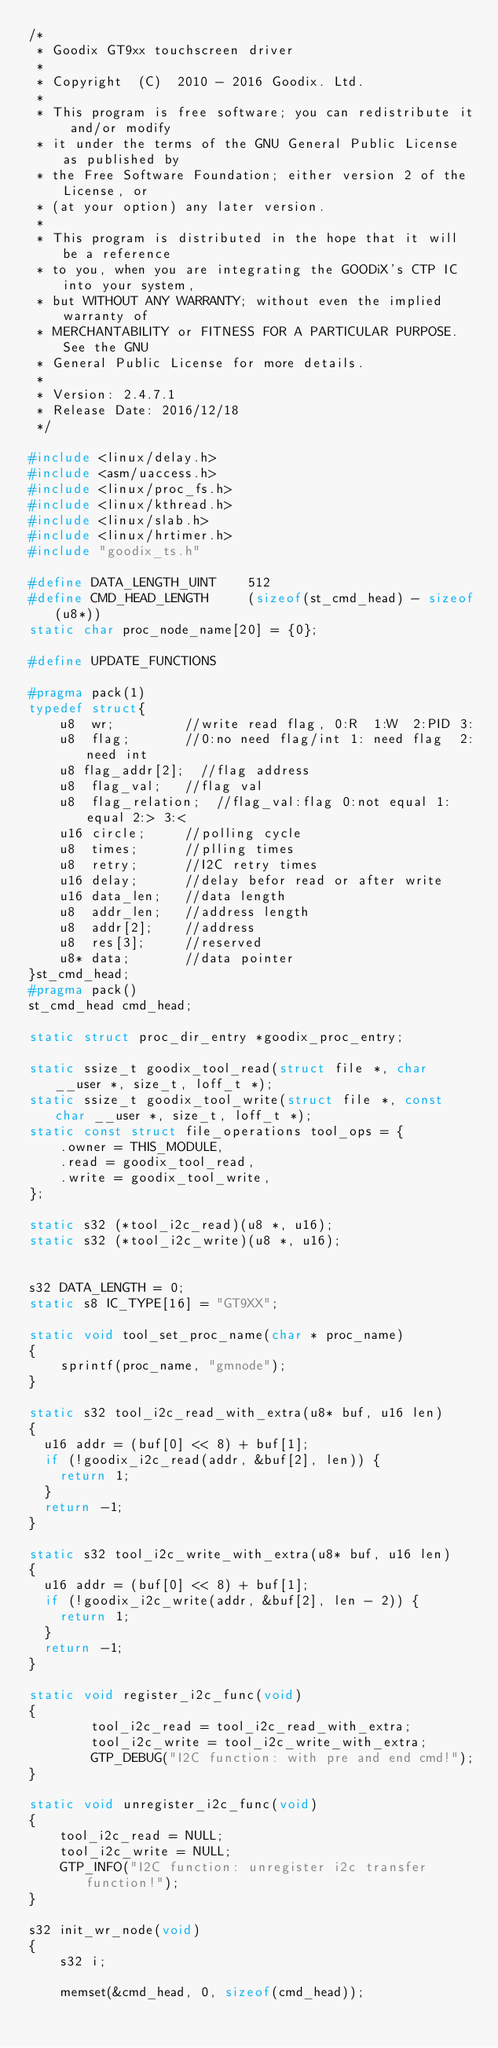Convert code to text. <code><loc_0><loc_0><loc_500><loc_500><_C_>/*
 * Goodix GT9xx touchscreen driver
 *
 * Copyright  (C)  2010 - 2016 Goodix. Ltd.
 *
 * This program is free software; you can redistribute it and/or modify
 * it under the terms of the GNU General Public License as published by
 * the Free Software Foundation; either version 2 of the License, or
 * (at your option) any later version.
 *
 * This program is distributed in the hope that it will be a reference
 * to you, when you are integrating the GOODiX's CTP IC into your system,
 * but WITHOUT ANY WARRANTY; without even the implied warranty of
 * MERCHANTABILITY or FITNESS FOR A PARTICULAR PURPOSE.  See the GNU
 * General Public License for more details.
 *
 * Version: 2.4.7.1
 * Release Date: 2016/12/18
 */

#include <linux/delay.h>
#include <asm/uaccess.h>
#include <linux/proc_fs.h>
#include <linux/kthread.h>
#include <linux/slab.h>
#include <linux/hrtimer.h>
#include "goodix_ts.h"

#define DATA_LENGTH_UINT    512
#define CMD_HEAD_LENGTH     (sizeof(st_cmd_head) - sizeof(u8*))
static char proc_node_name[20] = {0};

#define UPDATE_FUNCTIONS

#pragma pack(1)
typedef struct{
    u8  wr;         //write read flag, 0:R  1:W  2:PID 3:
    u8  flag;       //0:no need flag/int 1: need flag  2:need int
    u8 flag_addr[2];  //flag address
    u8  flag_val;   //flag val
    u8  flag_relation;  //flag_val:flag 0:not equal 1:equal 2:> 3:<
    u16 circle;     //polling cycle
    u8  times;      //plling times
    u8  retry;      //I2C retry times
    u16 delay;      //delay befor read or after write
    u16 data_len;   //data length
    u8  addr_len;   //address length
    u8  addr[2];    //address
    u8  res[3];     //reserved
    u8* data;       //data pointer
}st_cmd_head;
#pragma pack()
st_cmd_head cmd_head;

static struct proc_dir_entry *goodix_proc_entry;

static ssize_t goodix_tool_read(struct file *, char __user *, size_t, loff_t *);
static ssize_t goodix_tool_write(struct file *, const char __user *, size_t, loff_t *);
static const struct file_operations tool_ops = {
    .owner = THIS_MODULE,
    .read = goodix_tool_read,
    .write = goodix_tool_write,
};

static s32 (*tool_i2c_read)(u8 *, u16);
static s32 (*tool_i2c_write)(u8 *, u16);


s32 DATA_LENGTH = 0;
static s8 IC_TYPE[16] = "GT9XX";

static void tool_set_proc_name(char * proc_name)
{
    sprintf(proc_name, "gmnode");
}

static s32 tool_i2c_read_with_extra(u8* buf, u16 len)
{
	u16 addr = (buf[0] << 8) + buf[1];
	if (!goodix_i2c_read(addr, &buf[2], len)) {
		return 1;
	}
	return -1;
}

static s32 tool_i2c_write_with_extra(u8* buf, u16 len)
{
	u16 addr = (buf[0] << 8) + buf[1];
	if (!goodix_i2c_write(addr, &buf[2], len - 2)) {
		return 1;
	}
	return -1;
}

static void register_i2c_func(void)
{
        tool_i2c_read = tool_i2c_read_with_extra;
        tool_i2c_write = tool_i2c_write_with_extra;
        GTP_DEBUG("I2C function: with pre and end cmd!");
}

static void unregister_i2c_func(void)
{
    tool_i2c_read = NULL;
    tool_i2c_write = NULL;
    GTP_INFO("I2C function: unregister i2c transfer function!");
}

s32 init_wr_node(void)
{
    s32 i;

    memset(&cmd_head, 0, sizeof(cmd_head));</code> 